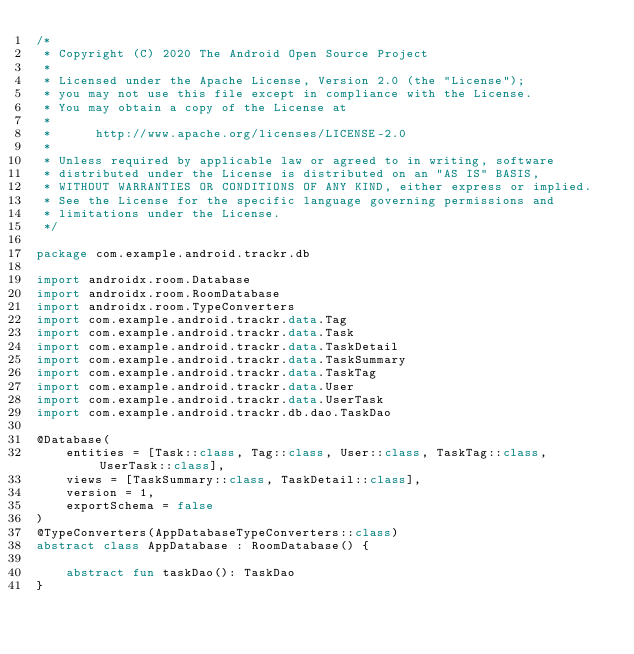<code> <loc_0><loc_0><loc_500><loc_500><_Kotlin_>/*
 * Copyright (C) 2020 The Android Open Source Project
 *
 * Licensed under the Apache License, Version 2.0 (the "License");
 * you may not use this file except in compliance with the License.
 * You may obtain a copy of the License at
 *
 *      http://www.apache.org/licenses/LICENSE-2.0
 *
 * Unless required by applicable law or agreed to in writing, software
 * distributed under the License is distributed on an "AS IS" BASIS,
 * WITHOUT WARRANTIES OR CONDITIONS OF ANY KIND, either express or implied.
 * See the License for the specific language governing permissions and
 * limitations under the License.
 */

package com.example.android.trackr.db

import androidx.room.Database
import androidx.room.RoomDatabase
import androidx.room.TypeConverters
import com.example.android.trackr.data.Tag
import com.example.android.trackr.data.Task
import com.example.android.trackr.data.TaskDetail
import com.example.android.trackr.data.TaskSummary
import com.example.android.trackr.data.TaskTag
import com.example.android.trackr.data.User
import com.example.android.trackr.data.UserTask
import com.example.android.trackr.db.dao.TaskDao

@Database(
    entities = [Task::class, Tag::class, User::class, TaskTag::class, UserTask::class],
    views = [TaskSummary::class, TaskDetail::class],
    version = 1,
    exportSchema = false
)
@TypeConverters(AppDatabaseTypeConverters::class)
abstract class AppDatabase : RoomDatabase() {

    abstract fun taskDao(): TaskDao
}
</code> 